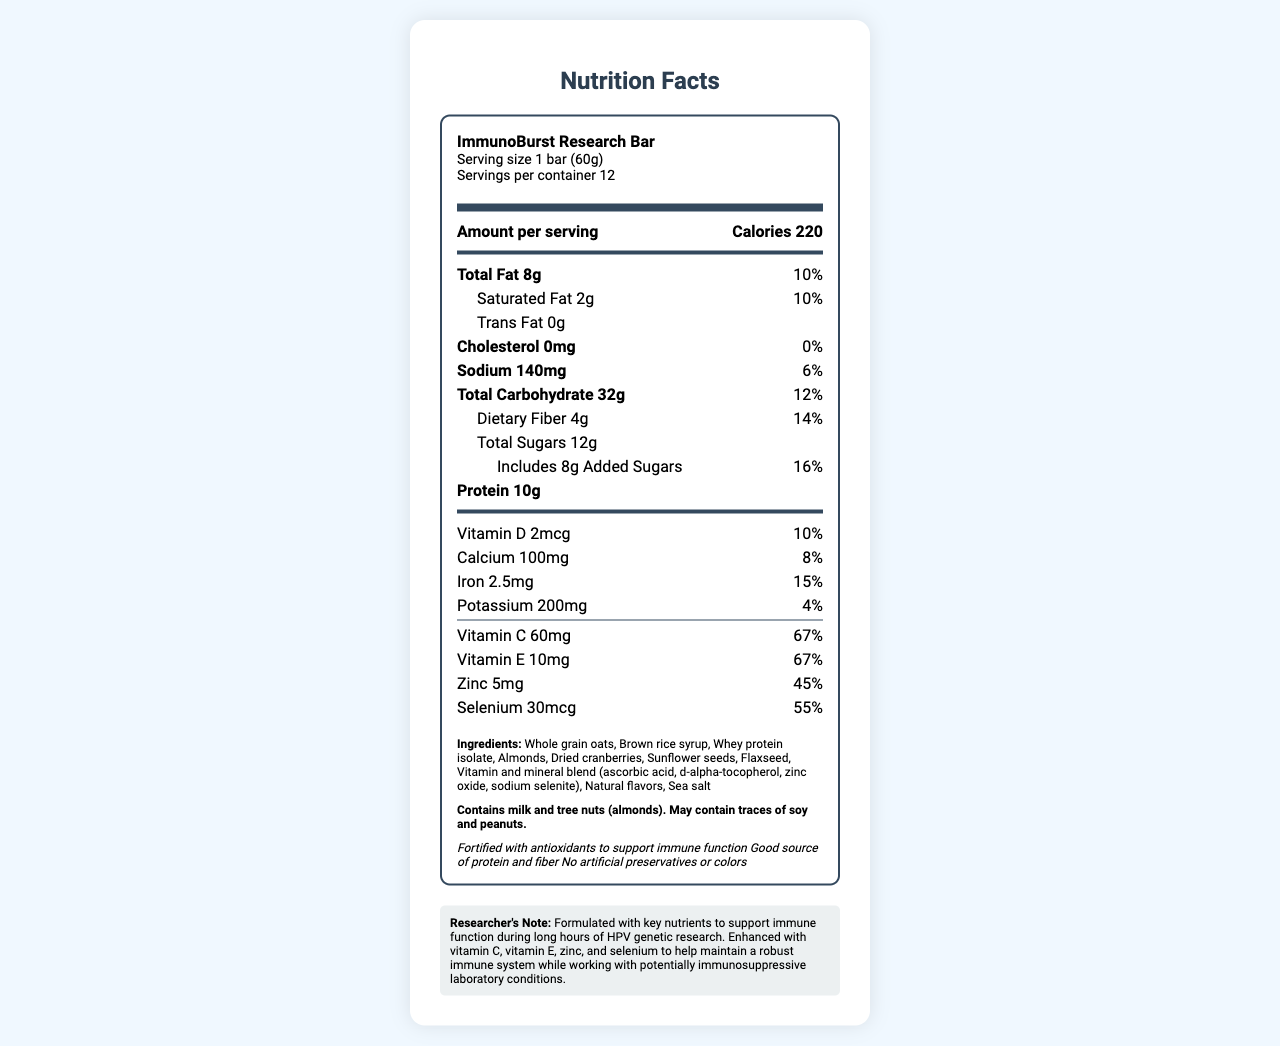what is the serving size of a single ImmunoBurst Research Bar? The document specifies that the serving size for a single ImmunoBurst Research Bar is 1 bar (60g).
Answer: 1 bar (60g) how many calories are in one serving of the ImmunoBurst Research Bar? The amount of calories per serving is clearly listed as 220 in the document.
Answer: 220 calories what percentage of the daily value of Vitamin C is provided per serving? The document states that one serving of the ImmunoBurst Research Bar provides 67% of the daily value of Vitamin C.
Answer: 67% what are the main allergens present in the ImmunoBurst Research Bar? The allergen information section states that the ImmunoBurst Research Bar contains milk and tree nuts (almonds).
Answer: Milk and tree nuts (almonds) how much protein does one ImmunoBurst Research Bar contain? The document specifies that each bar contains 10 grams of protein.
Answer: 10g which of the following nutrients is NOT included as added antioxidants in the ImmunoBurst Research Bar? A. Vitamin C B. Vitamin E C. Zinc D. Calcium The document lists Vitamin C, Vitamin E, and Zinc, but not Calcium, as added antioxidants.
Answer: D. Calcium what is a potential issue for individuals allergic to peanuts in consuming the ImmunoBurst Research Bar? A. Contains peanuts B. May contain traces of peanuts C. Contains peanut oil D. No issue The document indicates that the product may contain traces of peanuts, which could be a potential issue for individuals with peanut allergies.
Answer: B. May contain traces of peanuts is this energy bar a good source of fiber? The document claims that the bar is a good source of protein and fiber, and it provides 14% of the daily value of dietary fiber.
Answer: Yes how many servings are there per container of the ImmunoBurst Research Bar? The document specifies that there are 12 servings per container.
Answer: 12 list three of the claim statements made about the ImmunoBurst Research Bar. These claim statements are explicitly listed in the document.
Answer: Fortified with antioxidants to support immune function, good source of protein and fiber, no artificial preservatives or colors which nutrient has the highest percentage of daily value per serving? A. Vitamin A B. Vitamin C C. Iron D. Zinc The document specifies that Vitamin C provides 67% of the daily value per serving, which is the highest among the listed nutrients.
Answer: B. Vitamin C how many grams of saturated fat are in one serving? The serving details specify that there are 2 grams of saturated fat per serving.
Answer: 2g can the exact formulation process of the ImmunoBurst Research Bar be determined from this document? The document does not provide any details about the specific formulation process used to make the energy bar.
Answer: Cannot be determined summarize the main focus and content of this document. The summary captures the essential information about the bar, including its nutritional values, ingredients, allergen warnings, and specific health claims made to support the immune system of researchers.
Answer: The document is a nutrition facts label for the ImmunoBurst Research Bar, which contains detailed information about the serving size, nutritional content, ingredients, allergen information, and health claims. The bar is fortified with various antioxidants to support immune function, specifically tailored for researchers working in potentially immunosuppressive environments. 